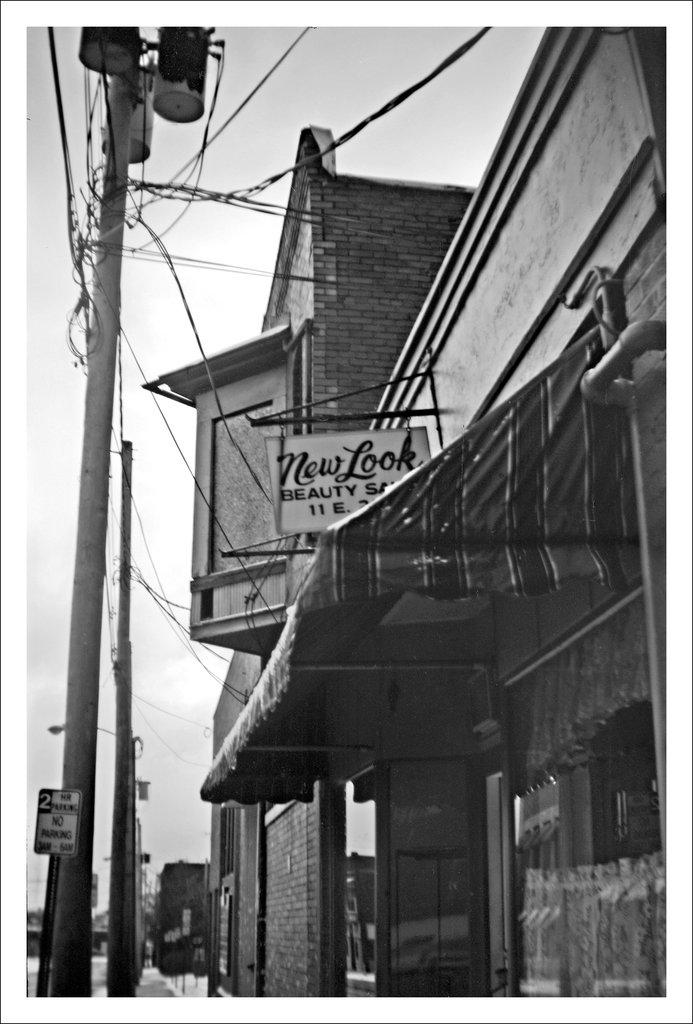What type of structures can be seen in the image? There are buildings in the image. What is present to provide shade in the image? There is a sun shade in the image. What can be found to display information in the image? There is a signboard in the image. What are the vertical supports in the image? There are poles in the image. What is strung between the poles in the image? There are wires in the image. What can be seen in the distance in the image? The sky is visible in the background of the image. How many sacks are being used to store wealth in the image? There are no sacks or references to wealth in the image. What type of notebook is being used by the person in the image? There is no person or notebook present in the image. 